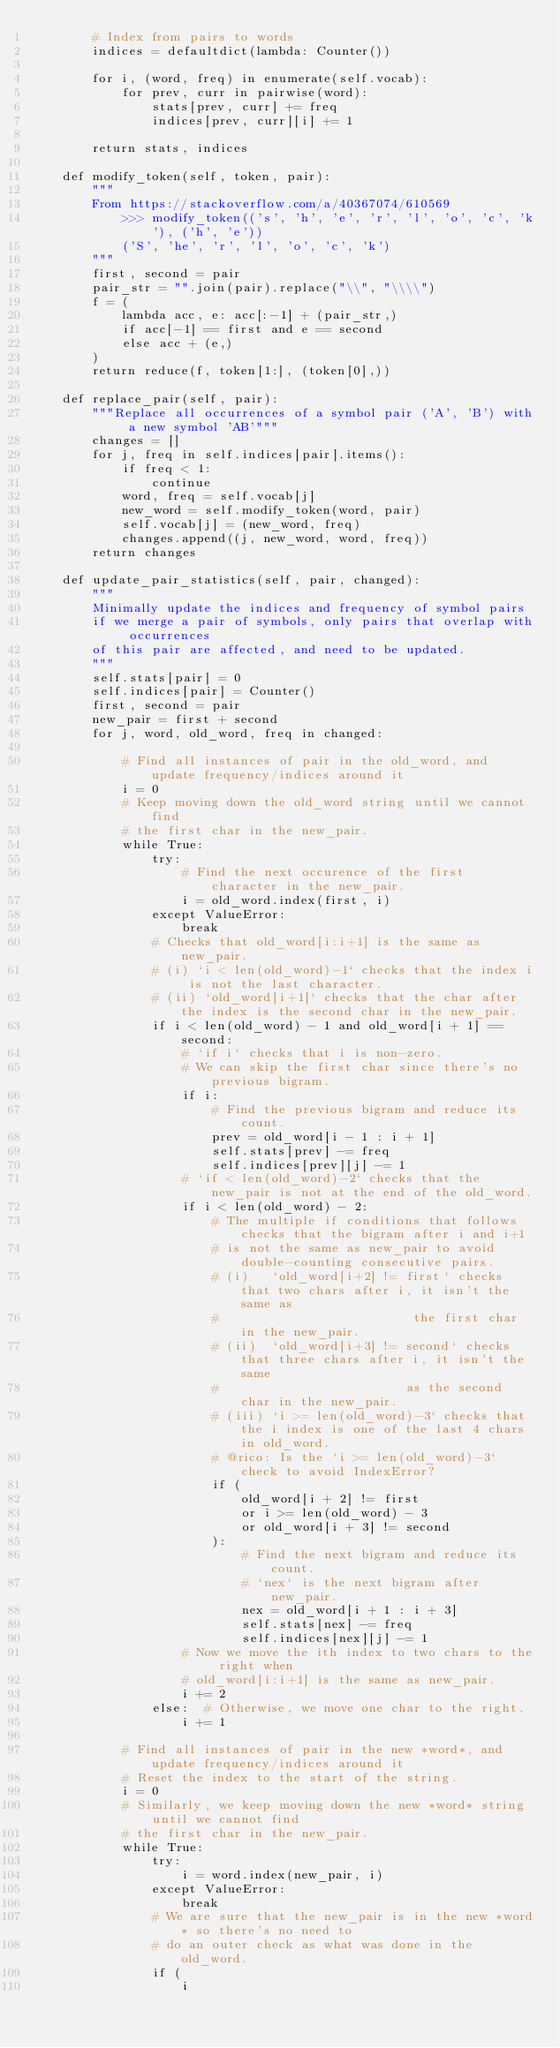Convert code to text. <code><loc_0><loc_0><loc_500><loc_500><_Python_>        # Index from pairs to words
        indices = defaultdict(lambda: Counter())

        for i, (word, freq) in enumerate(self.vocab):
            for prev, curr in pairwise(word):
                stats[prev, curr] += freq
                indices[prev, curr][i] += 1

        return stats, indices

    def modify_token(self, token, pair):
        """
        From https://stackoverflow.com/a/40367074/610569
            >>> modify_token(('s', 'h', 'e', 'r', 'l', 'o', 'c', 'k'), ('h', 'e'))
            ('S', 'he', 'r', 'l', 'o', 'c', 'k')
        """
        first, second = pair
        pair_str = "".join(pair).replace("\\", "\\\\")
        f = (
            lambda acc, e: acc[:-1] + (pair_str,)
            if acc[-1] == first and e == second
            else acc + (e,)
        )
        return reduce(f, token[1:], (token[0],))

    def replace_pair(self, pair):
        """Replace all occurrences of a symbol pair ('A', 'B') with a new symbol 'AB'"""
        changes = []
        for j, freq in self.indices[pair].items():
            if freq < 1:
                continue
            word, freq = self.vocab[j]
            new_word = self.modify_token(word, pair)
            self.vocab[j] = (new_word, freq)
            changes.append((j, new_word, word, freq))
        return changes

    def update_pair_statistics(self, pair, changed):
        """
        Minimally update the indices and frequency of symbol pairs
        if we merge a pair of symbols, only pairs that overlap with occurrences
        of this pair are affected, and need to be updated.
        """
        self.stats[pair] = 0
        self.indices[pair] = Counter()
        first, second = pair
        new_pair = first + second
        for j, word, old_word, freq in changed:

            # Find all instances of pair in the old_word, and update frequency/indices around it
            i = 0
            # Keep moving down the old_word string until we cannot find
            # the first char in the new_pair.
            while True:
                try:
                    # Find the next occurence of the first character in the new_pair.
                    i = old_word.index(first, i)
                except ValueError:
                    break
                # Checks that old_word[i:i+1] is the same as new_pair.
                # (i) `i < len(old_word)-1` checks that the index i is not the last character.
                # (ii) `old_word[i+1]` checks that the char after the index is the second char in the new_pair.
                if i < len(old_word) - 1 and old_word[i + 1] == second:
                    # `if i` checks that i is non-zero.
                    # We can skip the first char since there's no previous bigram.
                    if i:
                        # Find the previous bigram and reduce its count.
                        prev = old_word[i - 1 : i + 1]
                        self.stats[prev] -= freq
                        self.indices[prev][j] -= 1
                    # `if < len(old_word)-2` checks that the new_pair is not at the end of the old_word.
                    if i < len(old_word) - 2:
                        # The multiple if conditions that follows checks that the bigram after i and i+1
                        # is not the same as new_pair to avoid double-counting consecutive pairs.
                        # (i)   `old_word[i+2] != first` checks that two chars after i, it isn't the same as
                        #                          the first char in the new_pair.
                        # (ii)  `old_word[i+3] != second` checks that three chars after i, it isn't the same
                        #                         as the second char in the new_pair.
                        # (iii) `i >= len(old_word)-3` checks that the i index is one of the last 4 chars in old_word.
                        # @rico: Is the `i >= len(old_word)-3` check to avoid IndexError?
                        if (
                            old_word[i + 2] != first
                            or i >= len(old_word) - 3
                            or old_word[i + 3] != second
                        ):
                            # Find the next bigram and reduce its count.
                            # `nex` is the next bigram after new_pair.
                            nex = old_word[i + 1 : i + 3]
                            self.stats[nex] -= freq
                            self.indices[nex][j] -= 1
                    # Now we move the ith index to two chars to the right when
                    # old_word[i:i+1] is the same as new_pair.
                    i += 2
                else:  # Otherwise, we move one char to the right.
                    i += 1

            # Find all instances of pair in the new *word*, and update frequency/indices around it
            # Reset the index to the start of the string.
            i = 0
            # Similarly, we keep moving down the new *word* string until we cannot find
            # the first char in the new_pair.
            while True:
                try:
                    i = word.index(new_pair, i)
                except ValueError:
                    break
                # We are sure that the new_pair is in the new *word* so there's no need to
                # do an outer check as what was done in the old_word.
                if (
                    i</code> 